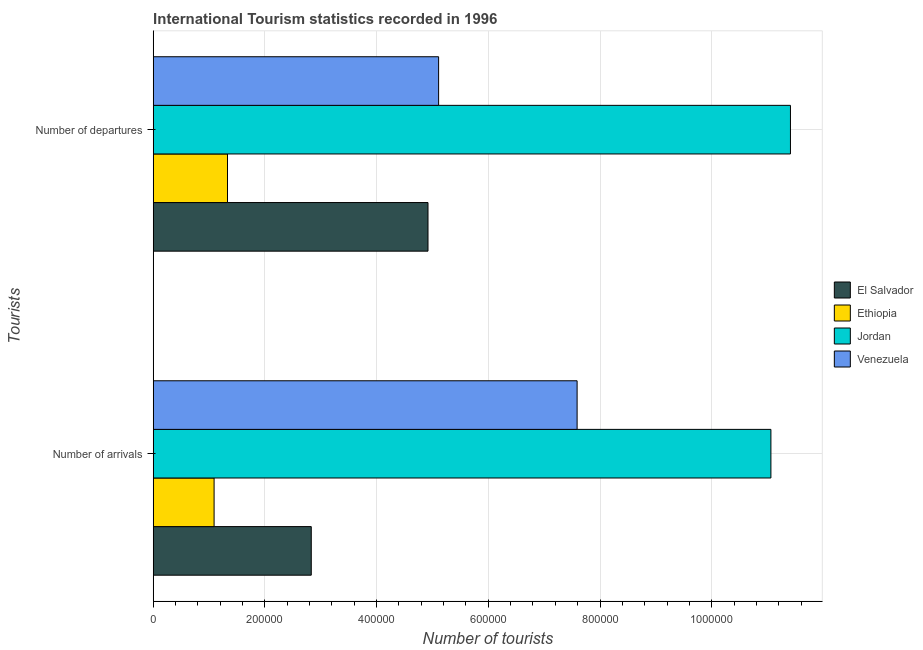How many groups of bars are there?
Offer a terse response. 2. Are the number of bars on each tick of the Y-axis equal?
Keep it short and to the point. Yes. How many bars are there on the 1st tick from the bottom?
Make the answer very short. 4. What is the label of the 2nd group of bars from the top?
Ensure brevity in your answer.  Number of arrivals. What is the number of tourist departures in Venezuela?
Keep it short and to the point. 5.11e+05. Across all countries, what is the maximum number of tourist arrivals?
Offer a very short reply. 1.11e+06. Across all countries, what is the minimum number of tourist departures?
Your response must be concise. 1.33e+05. In which country was the number of tourist arrivals maximum?
Provide a succinct answer. Jordan. In which country was the number of tourist departures minimum?
Provide a succinct answer. Ethiopia. What is the total number of tourist arrivals in the graph?
Your answer should be very brief. 2.26e+06. What is the difference between the number of tourist departures in El Salvador and that in Ethiopia?
Offer a very short reply. 3.59e+05. What is the difference between the number of tourist arrivals in Ethiopia and the number of tourist departures in El Salvador?
Provide a succinct answer. -3.83e+05. What is the average number of tourist arrivals per country?
Make the answer very short. 5.64e+05. What is the difference between the number of tourist departures and number of tourist arrivals in El Salvador?
Provide a short and direct response. 2.09e+05. What is the ratio of the number of tourist departures in Jordan to that in Venezuela?
Your answer should be very brief. 2.23. In how many countries, is the number of tourist departures greater than the average number of tourist departures taken over all countries?
Offer a terse response. 1. What does the 2nd bar from the top in Number of departures represents?
Your answer should be compact. Jordan. What does the 2nd bar from the bottom in Number of arrivals represents?
Make the answer very short. Ethiopia. Does the graph contain any zero values?
Make the answer very short. No. Does the graph contain grids?
Give a very brief answer. Yes. How many legend labels are there?
Keep it short and to the point. 4. How are the legend labels stacked?
Your answer should be compact. Vertical. What is the title of the graph?
Offer a very short reply. International Tourism statistics recorded in 1996. Does "Gambia, The" appear as one of the legend labels in the graph?
Provide a succinct answer. No. What is the label or title of the X-axis?
Provide a succinct answer. Number of tourists. What is the label or title of the Y-axis?
Provide a short and direct response. Tourists. What is the Number of tourists in El Salvador in Number of arrivals?
Give a very brief answer. 2.83e+05. What is the Number of tourists in Ethiopia in Number of arrivals?
Keep it short and to the point. 1.09e+05. What is the Number of tourists of Jordan in Number of arrivals?
Offer a terse response. 1.11e+06. What is the Number of tourists of Venezuela in Number of arrivals?
Provide a succinct answer. 7.59e+05. What is the Number of tourists of El Salvador in Number of departures?
Give a very brief answer. 4.92e+05. What is the Number of tourists in Ethiopia in Number of departures?
Your response must be concise. 1.33e+05. What is the Number of tourists of Jordan in Number of departures?
Keep it short and to the point. 1.14e+06. What is the Number of tourists of Venezuela in Number of departures?
Offer a very short reply. 5.11e+05. Across all Tourists, what is the maximum Number of tourists in El Salvador?
Provide a succinct answer. 4.92e+05. Across all Tourists, what is the maximum Number of tourists of Ethiopia?
Provide a short and direct response. 1.33e+05. Across all Tourists, what is the maximum Number of tourists of Jordan?
Your answer should be very brief. 1.14e+06. Across all Tourists, what is the maximum Number of tourists in Venezuela?
Your answer should be very brief. 7.59e+05. Across all Tourists, what is the minimum Number of tourists in El Salvador?
Provide a short and direct response. 2.83e+05. Across all Tourists, what is the minimum Number of tourists in Ethiopia?
Your answer should be very brief. 1.09e+05. Across all Tourists, what is the minimum Number of tourists of Jordan?
Your answer should be compact. 1.11e+06. Across all Tourists, what is the minimum Number of tourists in Venezuela?
Provide a short and direct response. 5.11e+05. What is the total Number of tourists in El Salvador in the graph?
Provide a succinct answer. 7.75e+05. What is the total Number of tourists in Ethiopia in the graph?
Your answer should be very brief. 2.42e+05. What is the total Number of tourists of Jordan in the graph?
Ensure brevity in your answer.  2.25e+06. What is the total Number of tourists of Venezuela in the graph?
Make the answer very short. 1.27e+06. What is the difference between the Number of tourists in El Salvador in Number of arrivals and that in Number of departures?
Offer a terse response. -2.09e+05. What is the difference between the Number of tourists in Ethiopia in Number of arrivals and that in Number of departures?
Your response must be concise. -2.40e+04. What is the difference between the Number of tourists of Jordan in Number of arrivals and that in Number of departures?
Your answer should be very brief. -3.50e+04. What is the difference between the Number of tourists in Venezuela in Number of arrivals and that in Number of departures?
Provide a succinct answer. 2.48e+05. What is the difference between the Number of tourists in El Salvador in Number of arrivals and the Number of tourists in Ethiopia in Number of departures?
Keep it short and to the point. 1.50e+05. What is the difference between the Number of tourists of El Salvador in Number of arrivals and the Number of tourists of Jordan in Number of departures?
Provide a succinct answer. -8.58e+05. What is the difference between the Number of tourists of El Salvador in Number of arrivals and the Number of tourists of Venezuela in Number of departures?
Your answer should be very brief. -2.28e+05. What is the difference between the Number of tourists in Ethiopia in Number of arrivals and the Number of tourists in Jordan in Number of departures?
Your response must be concise. -1.03e+06. What is the difference between the Number of tourists of Ethiopia in Number of arrivals and the Number of tourists of Venezuela in Number of departures?
Keep it short and to the point. -4.02e+05. What is the difference between the Number of tourists of Jordan in Number of arrivals and the Number of tourists of Venezuela in Number of departures?
Your response must be concise. 5.95e+05. What is the average Number of tourists in El Salvador per Tourists?
Your response must be concise. 3.88e+05. What is the average Number of tourists of Ethiopia per Tourists?
Provide a succinct answer. 1.21e+05. What is the average Number of tourists in Jordan per Tourists?
Provide a succinct answer. 1.12e+06. What is the average Number of tourists in Venezuela per Tourists?
Give a very brief answer. 6.35e+05. What is the difference between the Number of tourists in El Salvador and Number of tourists in Ethiopia in Number of arrivals?
Your answer should be compact. 1.74e+05. What is the difference between the Number of tourists of El Salvador and Number of tourists of Jordan in Number of arrivals?
Provide a succinct answer. -8.23e+05. What is the difference between the Number of tourists in El Salvador and Number of tourists in Venezuela in Number of arrivals?
Your answer should be compact. -4.76e+05. What is the difference between the Number of tourists in Ethiopia and Number of tourists in Jordan in Number of arrivals?
Provide a succinct answer. -9.97e+05. What is the difference between the Number of tourists in Ethiopia and Number of tourists in Venezuela in Number of arrivals?
Offer a terse response. -6.50e+05. What is the difference between the Number of tourists in Jordan and Number of tourists in Venezuela in Number of arrivals?
Offer a terse response. 3.47e+05. What is the difference between the Number of tourists of El Salvador and Number of tourists of Ethiopia in Number of departures?
Your answer should be very brief. 3.59e+05. What is the difference between the Number of tourists of El Salvador and Number of tourists of Jordan in Number of departures?
Your response must be concise. -6.49e+05. What is the difference between the Number of tourists of El Salvador and Number of tourists of Venezuela in Number of departures?
Offer a very short reply. -1.90e+04. What is the difference between the Number of tourists in Ethiopia and Number of tourists in Jordan in Number of departures?
Your answer should be very brief. -1.01e+06. What is the difference between the Number of tourists of Ethiopia and Number of tourists of Venezuela in Number of departures?
Keep it short and to the point. -3.78e+05. What is the difference between the Number of tourists of Jordan and Number of tourists of Venezuela in Number of departures?
Give a very brief answer. 6.30e+05. What is the ratio of the Number of tourists in El Salvador in Number of arrivals to that in Number of departures?
Ensure brevity in your answer.  0.58. What is the ratio of the Number of tourists of Ethiopia in Number of arrivals to that in Number of departures?
Offer a very short reply. 0.82. What is the ratio of the Number of tourists of Jordan in Number of arrivals to that in Number of departures?
Make the answer very short. 0.97. What is the ratio of the Number of tourists in Venezuela in Number of arrivals to that in Number of departures?
Provide a short and direct response. 1.49. What is the difference between the highest and the second highest Number of tourists in El Salvador?
Ensure brevity in your answer.  2.09e+05. What is the difference between the highest and the second highest Number of tourists in Ethiopia?
Provide a succinct answer. 2.40e+04. What is the difference between the highest and the second highest Number of tourists in Jordan?
Offer a very short reply. 3.50e+04. What is the difference between the highest and the second highest Number of tourists in Venezuela?
Offer a very short reply. 2.48e+05. What is the difference between the highest and the lowest Number of tourists in El Salvador?
Your answer should be very brief. 2.09e+05. What is the difference between the highest and the lowest Number of tourists in Ethiopia?
Your answer should be very brief. 2.40e+04. What is the difference between the highest and the lowest Number of tourists in Jordan?
Your response must be concise. 3.50e+04. What is the difference between the highest and the lowest Number of tourists in Venezuela?
Your response must be concise. 2.48e+05. 